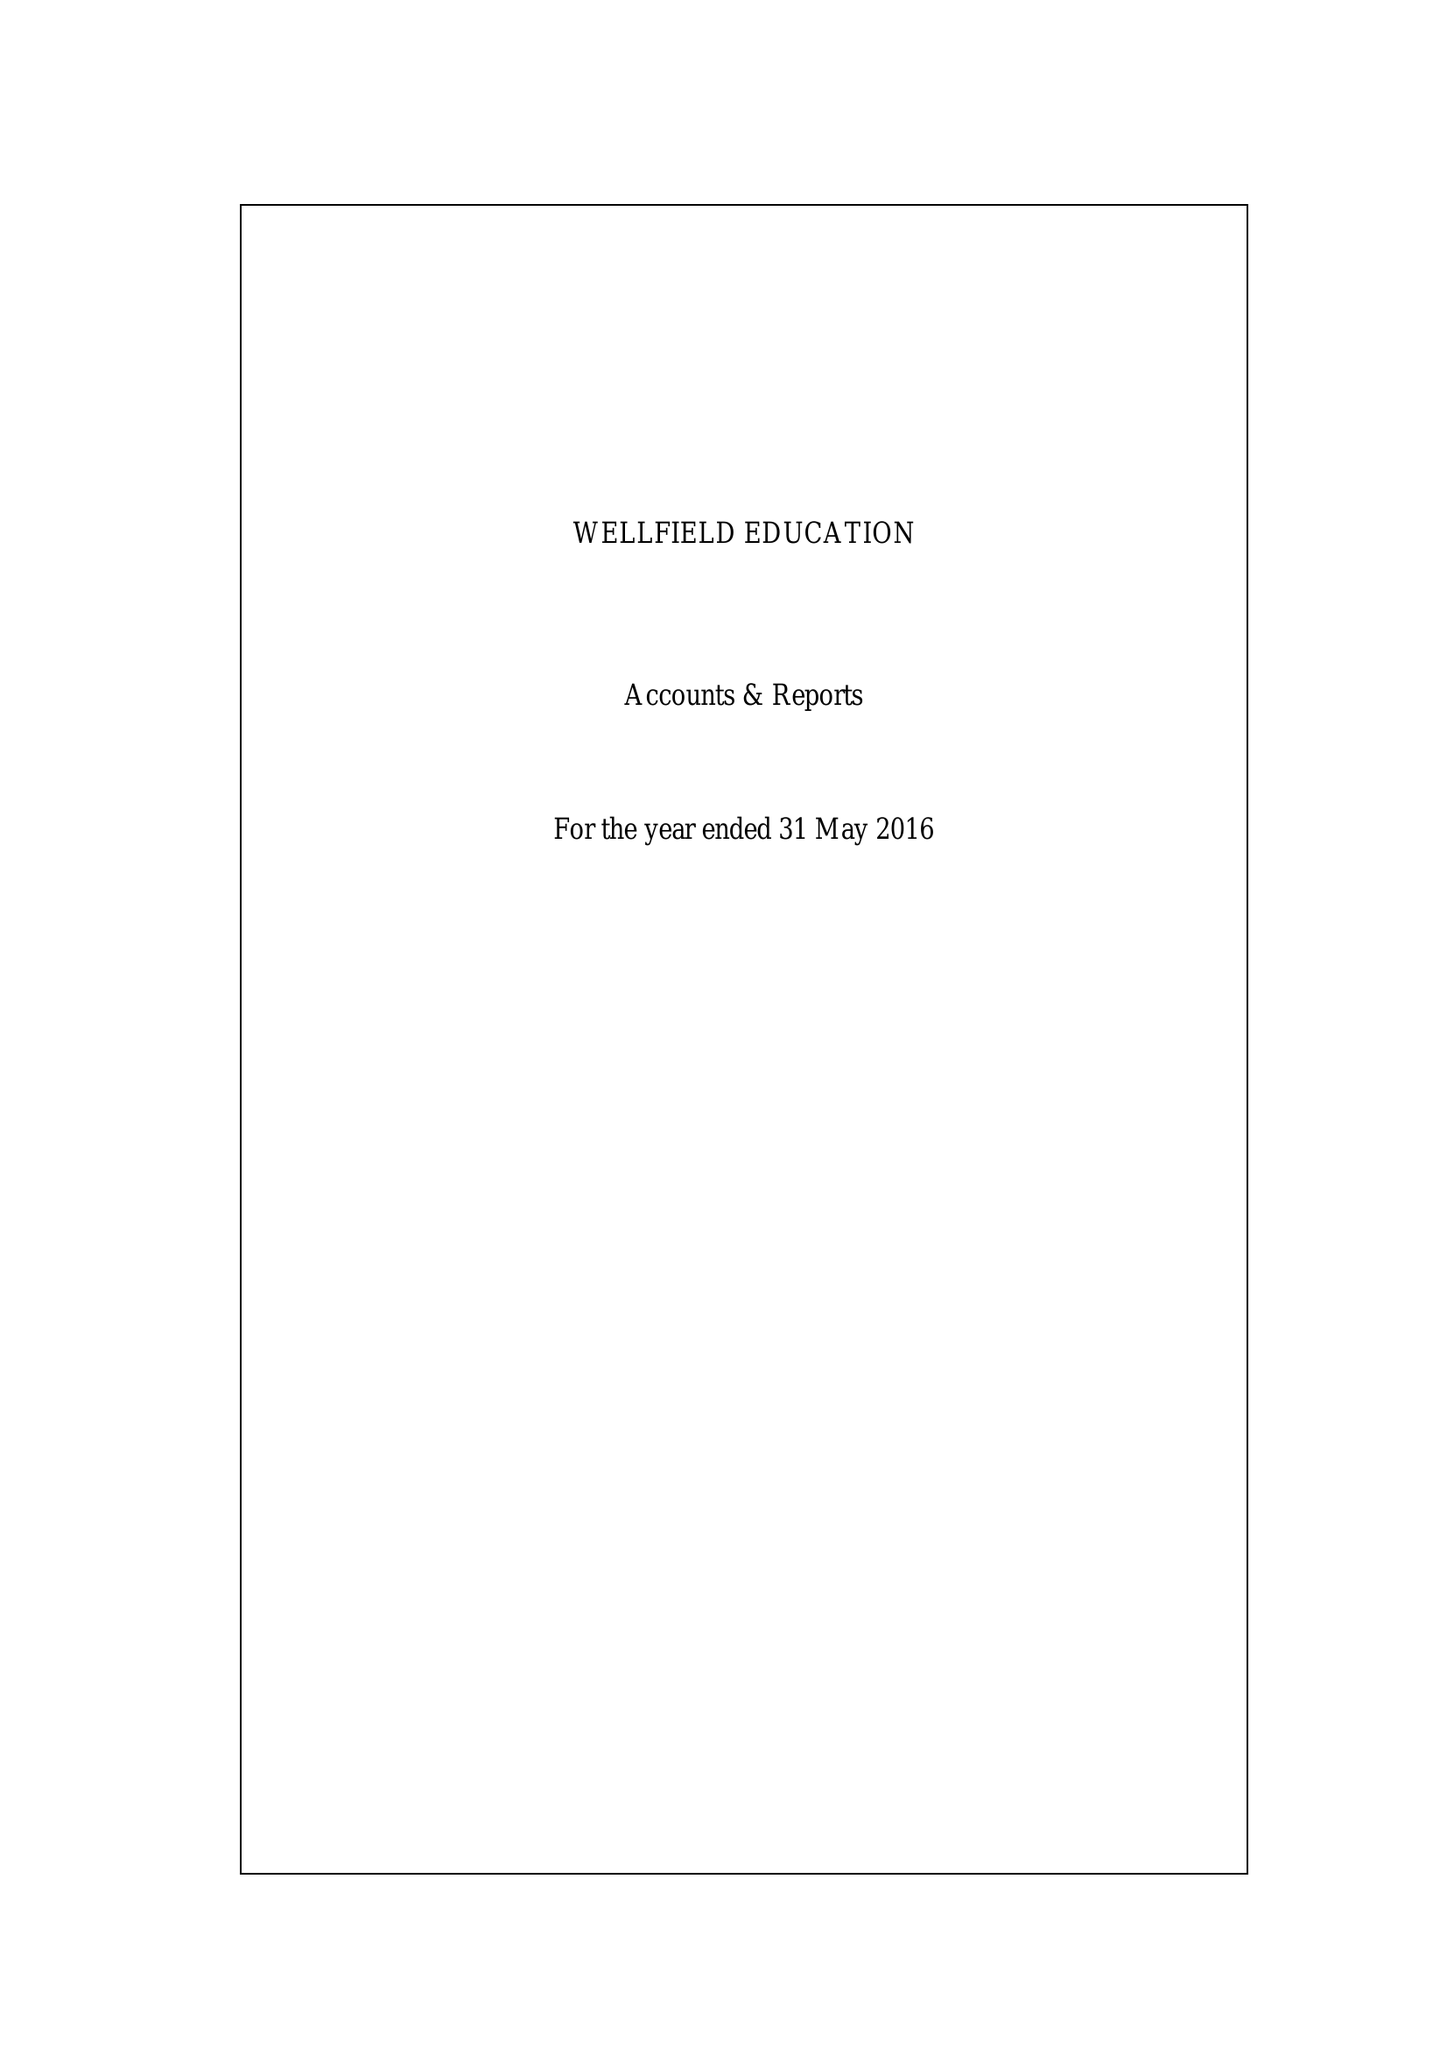What is the value for the charity_name?
Answer the question using a single word or phrase. Wellfield Education 